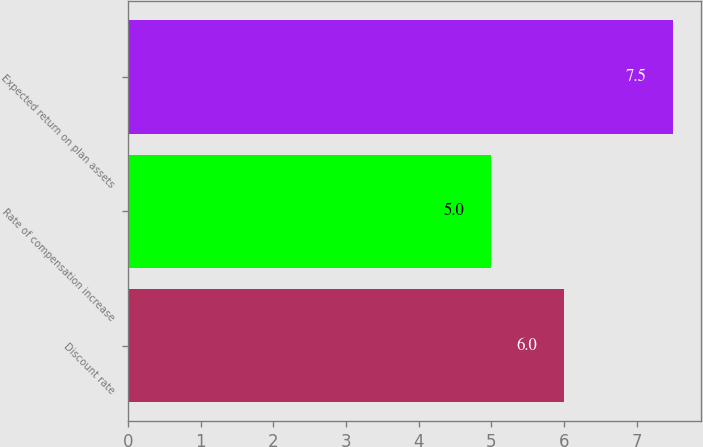Convert chart. <chart><loc_0><loc_0><loc_500><loc_500><bar_chart><fcel>Discount rate<fcel>Rate of compensation increase<fcel>Expected return on plan assets<nl><fcel>6<fcel>5<fcel>7.5<nl></chart> 